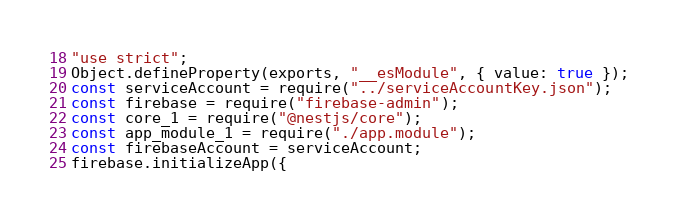<code> <loc_0><loc_0><loc_500><loc_500><_JavaScript_>"use strict";
Object.defineProperty(exports, "__esModule", { value: true });
const serviceAccount = require("../serviceAccountKey.json");
const firebase = require("firebase-admin");
const core_1 = require("@nestjs/core");
const app_module_1 = require("./app.module");
const firebaseAccount = serviceAccount;
firebase.initializeApp({</code> 